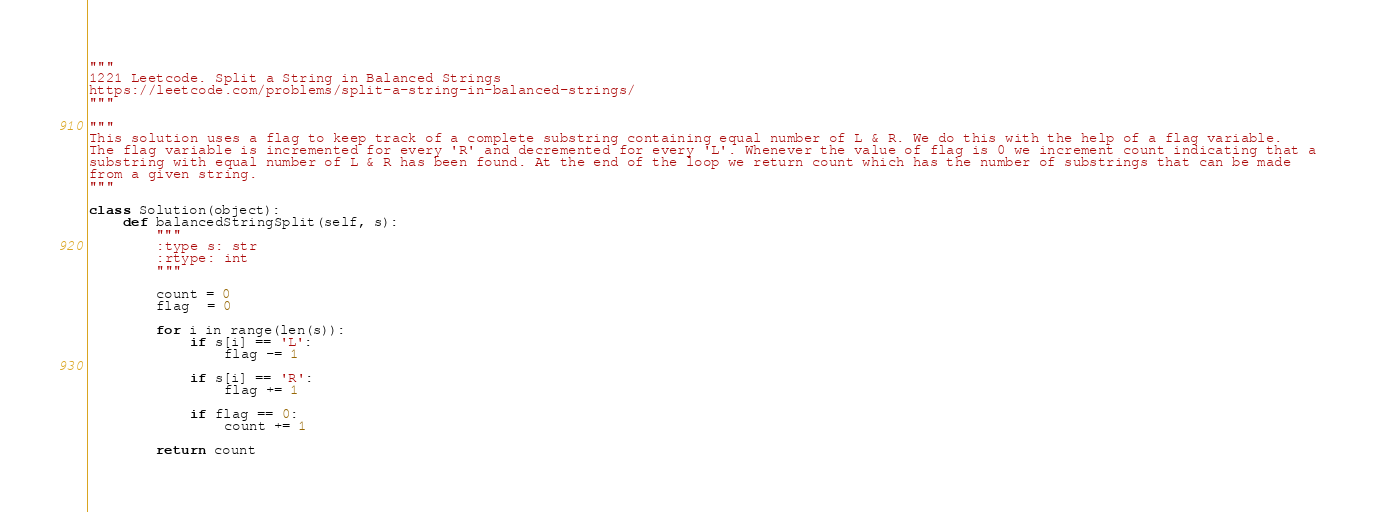<code> <loc_0><loc_0><loc_500><loc_500><_Python_>"""
1221 Leetcode. Split a String in Balanced Strings
https://leetcode.com/problems/split-a-string-in-balanced-strings/
"""

"""
This solution uses a flag to keep track of a complete substring containing equal number of L & R. We do this with the help of a flag variable.
The flag variable is incremented for every 'R' and decremented for every 'L'. Whenever the value of flag is 0 we increment count indicating that a
substring with equal number of L & R has been found. At the end of the loop we return count which has the number of substrings that can be made
from a given string.
"""

class Solution(object):
    def balancedStringSplit(self, s):
        """
        :type s: str
        :rtype: int
        """
                
        count = 0
        flag  = 0
        
        for i in range(len(s)):
            if s[i] == 'L':
                flag -= 1
                
            if s[i] == 'R':
                flag += 1
                
            if flag == 0:
                count += 1
                
        return count</code> 